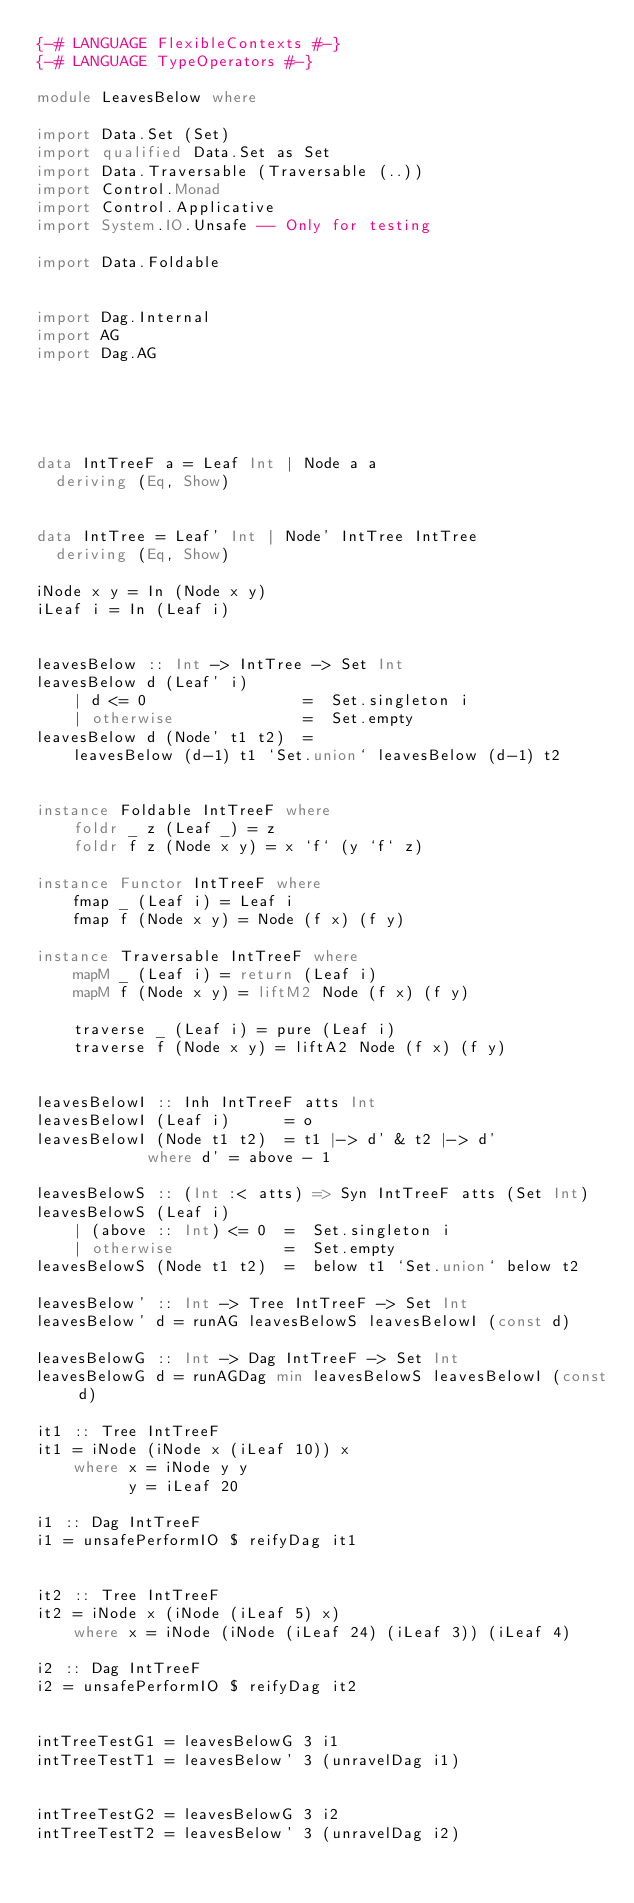Convert code to text. <code><loc_0><loc_0><loc_500><loc_500><_Haskell_>{-# LANGUAGE FlexibleContexts #-}
{-# LANGUAGE TypeOperators #-}

module LeavesBelow where

import Data.Set (Set)
import qualified Data.Set as Set
import Data.Traversable (Traversable (..))
import Control.Monad
import Control.Applicative
import System.IO.Unsafe -- Only for testing

import Data.Foldable


import Dag.Internal
import AG
import Dag.AG





data IntTreeF a = Leaf Int | Node a a
  deriving (Eq, Show)


data IntTree = Leaf' Int | Node' IntTree IntTree
  deriving (Eq, Show)

iNode x y = In (Node x y)
iLeaf i = In (Leaf i)


leavesBelow :: Int -> IntTree -> Set Int
leavesBelow d (Leaf' i)
    | d <= 0                 =  Set.singleton i
    | otherwise              =  Set.empty
leavesBelow d (Node' t1 t2)  =
    leavesBelow (d-1) t1 `Set.union` leavesBelow (d-1) t2


instance Foldable IntTreeF where
    foldr _ z (Leaf _) = z
    foldr f z (Node x y) = x `f` (y `f` z)

instance Functor IntTreeF where
    fmap _ (Leaf i) = Leaf i
    fmap f (Node x y) = Node (f x) (f y)

instance Traversable IntTreeF where
    mapM _ (Leaf i) = return (Leaf i)
    mapM f (Node x y) = liftM2 Node (f x) (f y)

    traverse _ (Leaf i) = pure (Leaf i)
    traverse f (Node x y) = liftA2 Node (f x) (f y)


leavesBelowI :: Inh IntTreeF atts Int
leavesBelowI (Leaf i)      = o
leavesBelowI (Node t1 t2)  = t1 |-> d' & t2 |-> d'
            where d' = above - 1

leavesBelowS :: (Int :< atts) => Syn IntTreeF atts (Set Int)
leavesBelowS (Leaf i)
    | (above :: Int) <= 0  =  Set.singleton i
    | otherwise            =  Set.empty
leavesBelowS (Node t1 t2)  =  below t1 `Set.union` below t2

leavesBelow' :: Int -> Tree IntTreeF -> Set Int
leavesBelow' d = runAG leavesBelowS leavesBelowI (const d)

leavesBelowG :: Int -> Dag IntTreeF -> Set Int
leavesBelowG d = runAGDag min leavesBelowS leavesBelowI (const d)

it1 :: Tree IntTreeF
it1 = iNode (iNode x (iLeaf 10)) x
    where x = iNode y y
          y = iLeaf 20

i1 :: Dag IntTreeF
i1 = unsafePerformIO $ reifyDag it1


it2 :: Tree IntTreeF
it2 = iNode x (iNode (iLeaf 5) x)
    where x = iNode (iNode (iLeaf 24) (iLeaf 3)) (iLeaf 4)

i2 :: Dag IntTreeF
i2 = unsafePerformIO $ reifyDag it2


intTreeTestG1 = leavesBelowG 3 i1
intTreeTestT1 = leavesBelow' 3 (unravelDag i1)


intTreeTestG2 = leavesBelowG 3 i2
intTreeTestT2 = leavesBelow' 3 (unravelDag i2)

</code> 